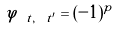Convert formula to latex. <formula><loc_0><loc_0><loc_500><loc_500>\tilde { \varphi } _ { \ t , \ t ^ { \prime } } = ( - 1 ) ^ { p }</formula> 